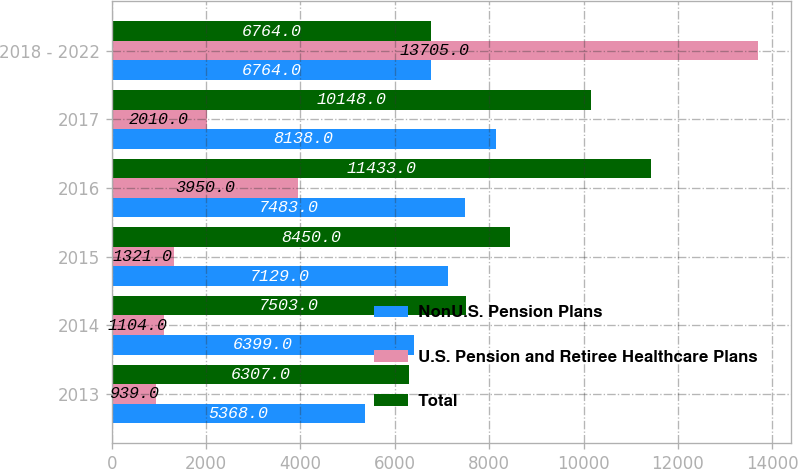<chart> <loc_0><loc_0><loc_500><loc_500><stacked_bar_chart><ecel><fcel>2013<fcel>2014<fcel>2015<fcel>2016<fcel>2017<fcel>2018 - 2022<nl><fcel>NonU.S. Pension Plans<fcel>5368<fcel>6399<fcel>7129<fcel>7483<fcel>8138<fcel>6764<nl><fcel>U.S. Pension and Retiree Healthcare Plans<fcel>939<fcel>1104<fcel>1321<fcel>3950<fcel>2010<fcel>13705<nl><fcel>Total<fcel>6307<fcel>7503<fcel>8450<fcel>11433<fcel>10148<fcel>6764<nl></chart> 